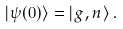Convert formula to latex. <formula><loc_0><loc_0><loc_500><loc_500>| \psi ( 0 ) \rangle = | g , n \rangle \, .</formula> 